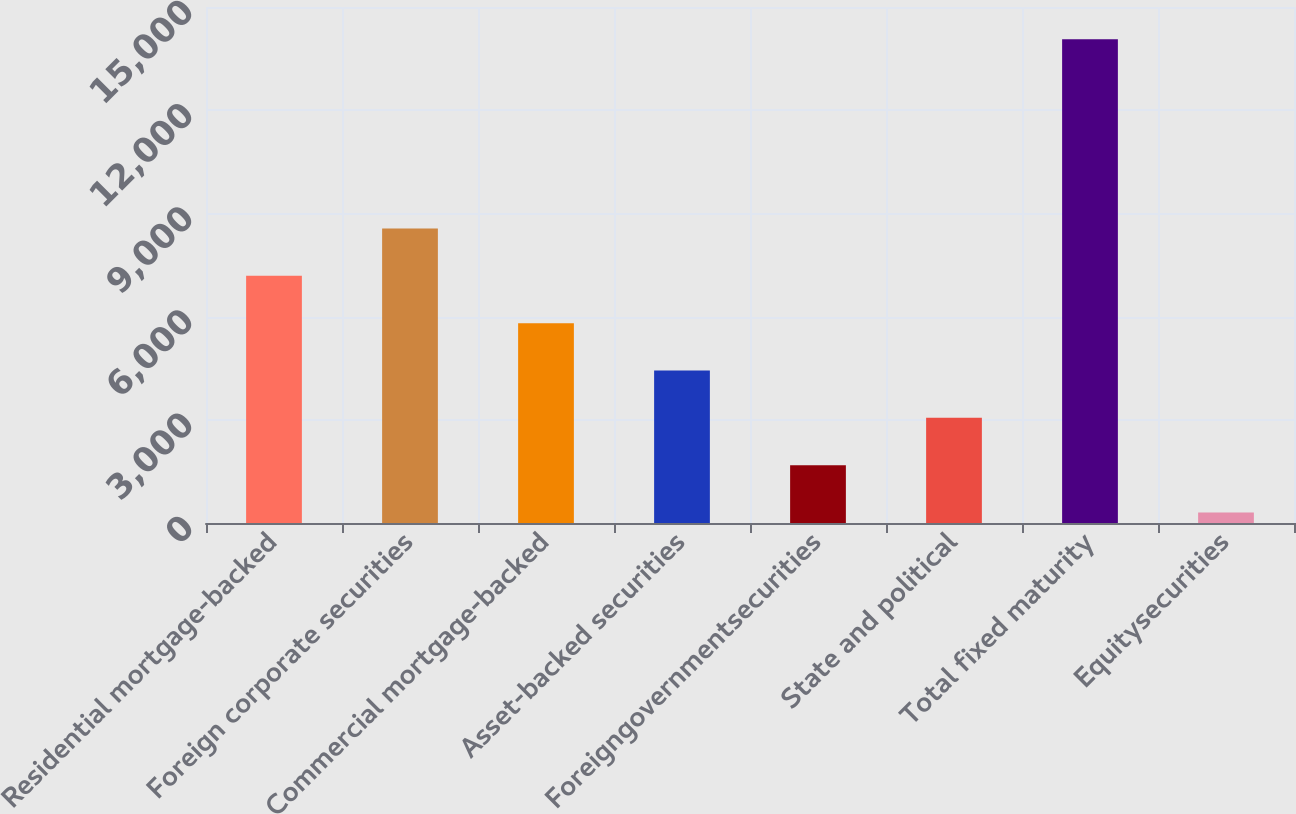<chart> <loc_0><loc_0><loc_500><loc_500><bar_chart><fcel>Residential mortgage-backed<fcel>Foreign corporate securities<fcel>Commercial mortgage-backed<fcel>Asset-backed securities<fcel>Foreigngovernmentsecurities<fcel>State and political<fcel>Total fixed maturity<fcel>Equitysecurities<nl><fcel>7184<fcel>8559.6<fcel>5808.4<fcel>4432.8<fcel>1681.6<fcel>3057.2<fcel>14062<fcel>306<nl></chart> 